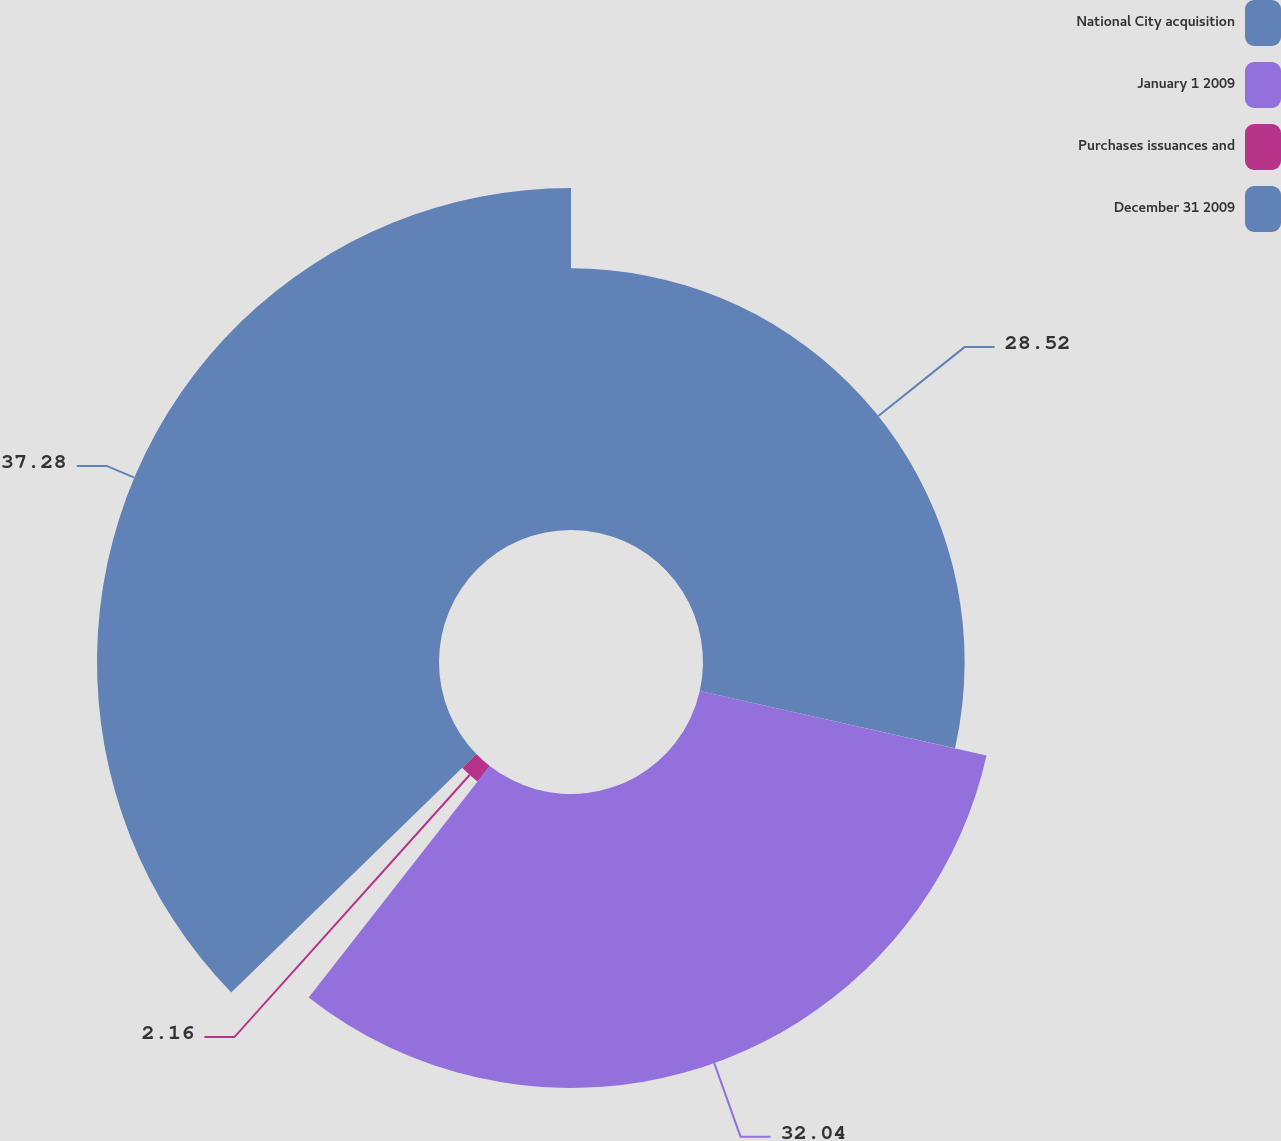<chart> <loc_0><loc_0><loc_500><loc_500><pie_chart><fcel>National City acquisition<fcel>January 1 2009<fcel>Purchases issuances and<fcel>December 31 2009<nl><fcel>28.52%<fcel>32.04%<fcel>2.16%<fcel>37.28%<nl></chart> 